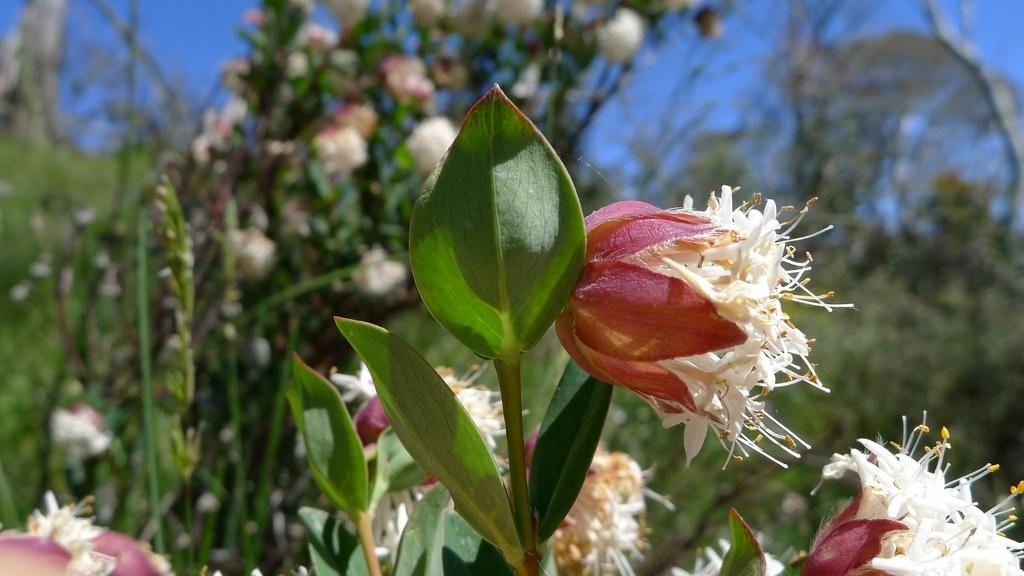What type of plants can be seen in the image? There are flower plants in the image. Can you describe the background of the image? The background of the image is blurred. What type of brake system is visible on the flower plants in the image? There is no brake system present on the flower plants in the image. 